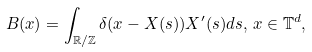<formula> <loc_0><loc_0><loc_500><loc_500>B ( x ) = \int _ { \mathbb { R / Z } } \delta ( x - X ( s ) ) X ^ { \prime } ( s ) d s , \, x \in \mathbb { T } ^ { d } ,</formula> 